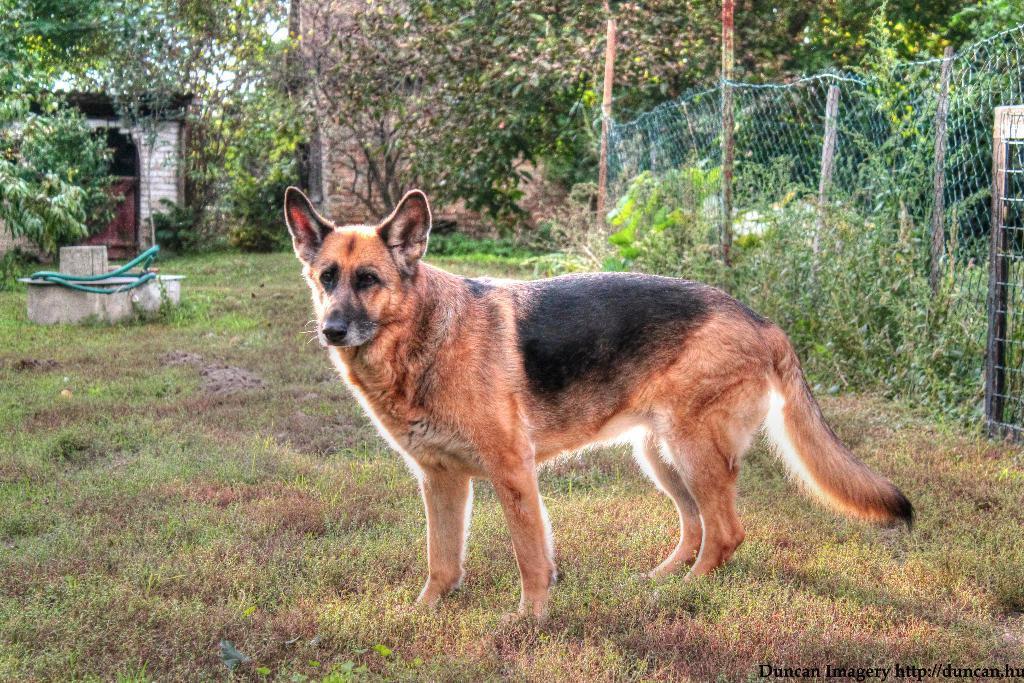Describe this image in one or two sentences. In the center of the image there is a dog on the grass. In the background of the image there are trees, buildings. To the right side of the image there is a fencing. 